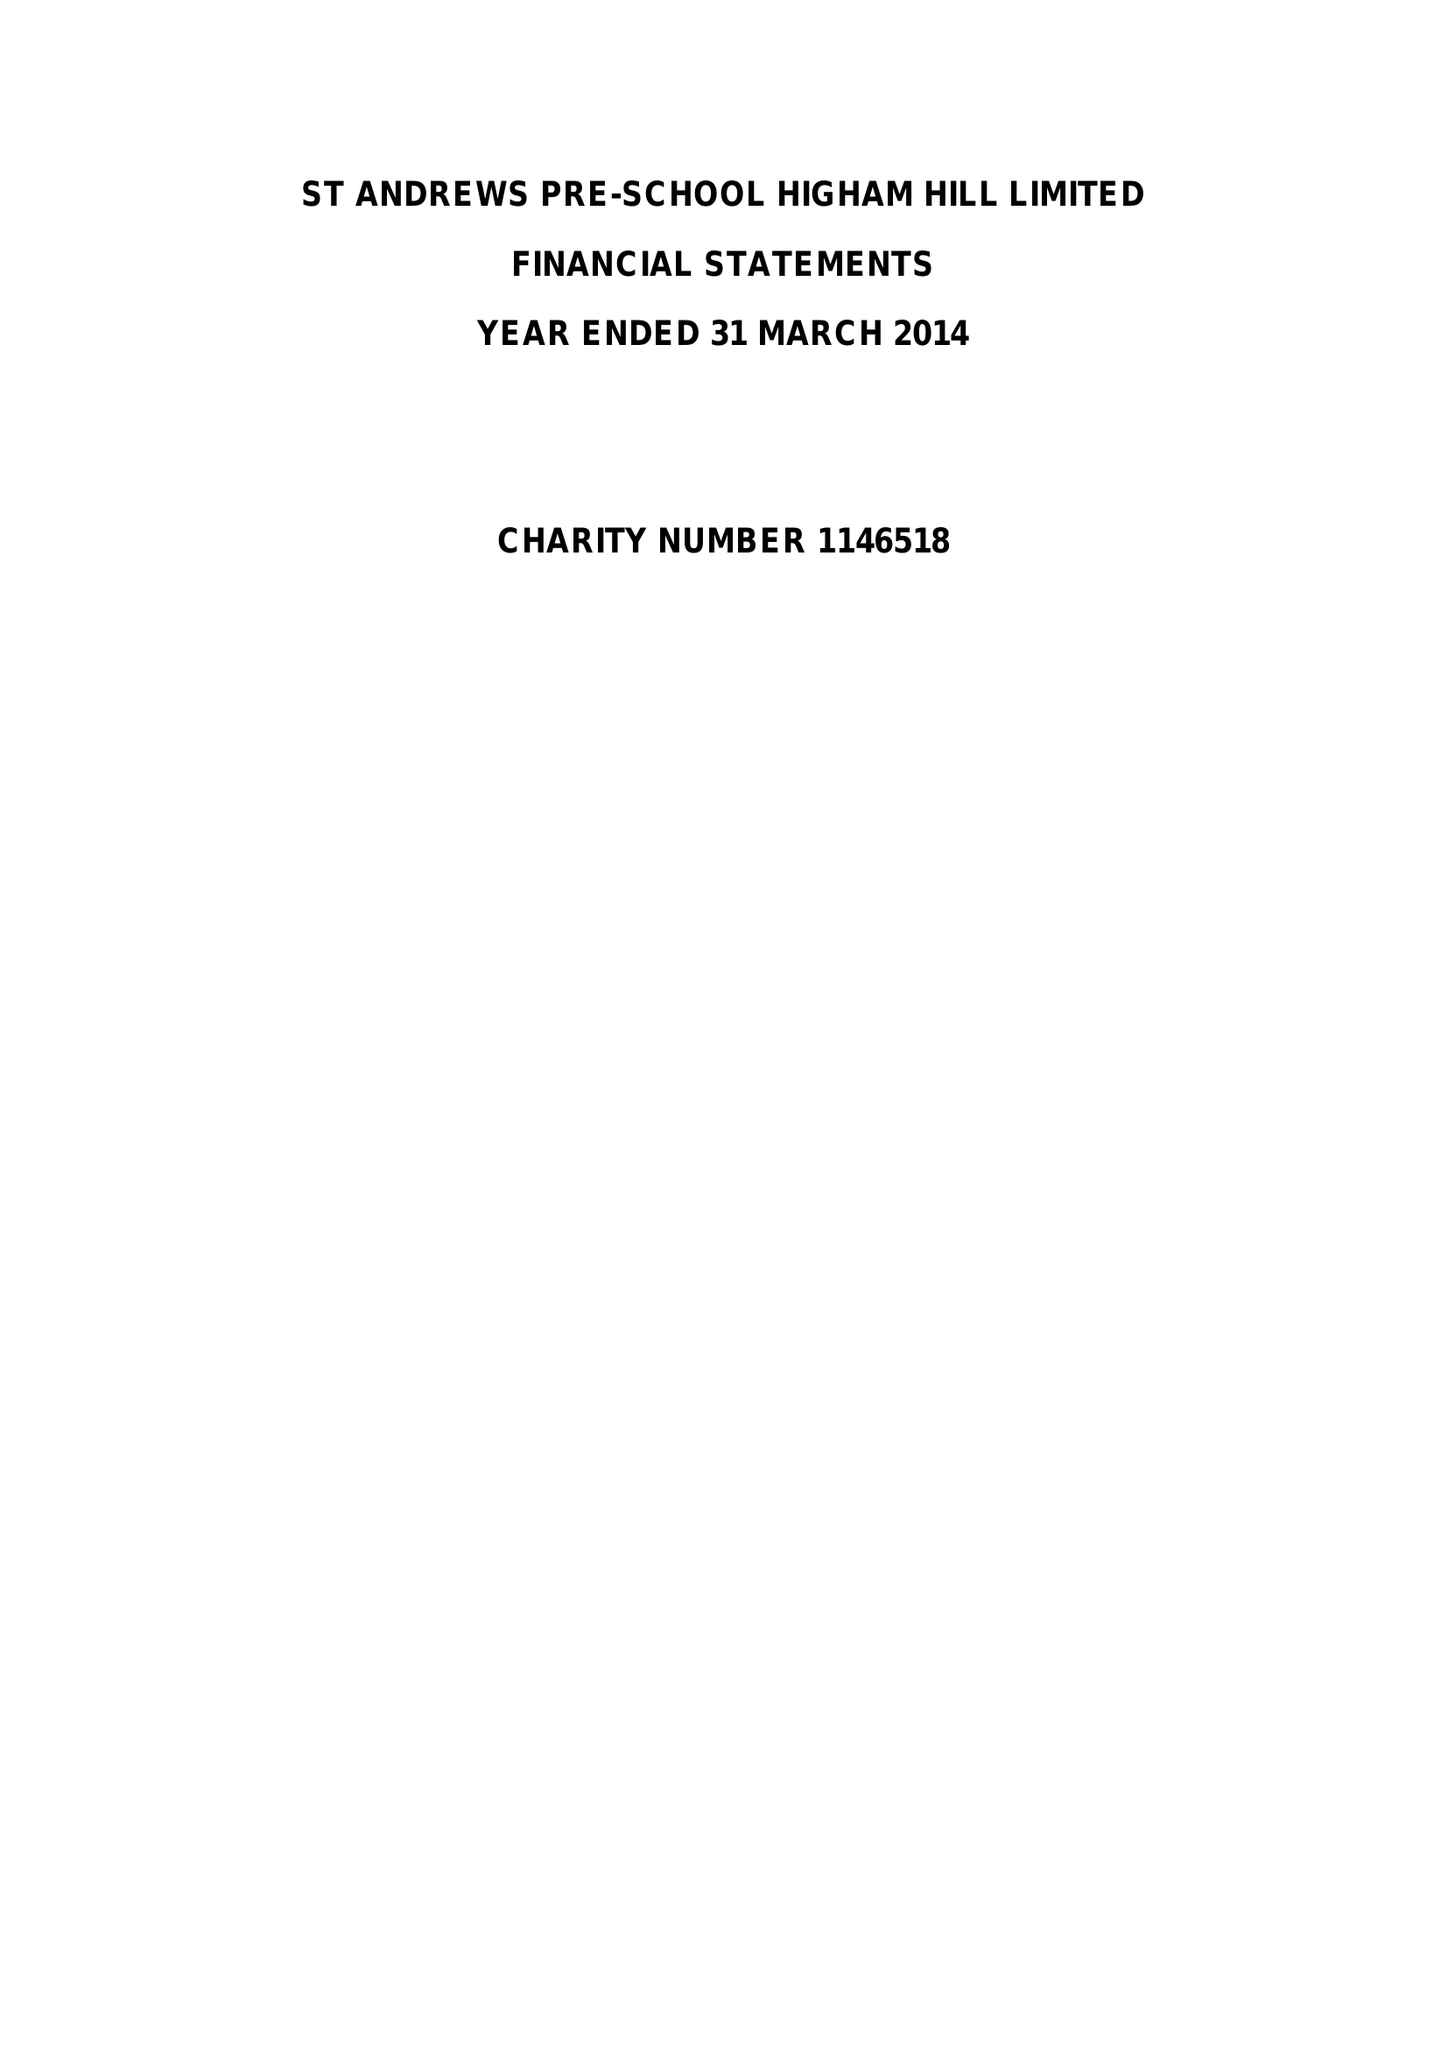What is the value for the report_date?
Answer the question using a single word or phrase. 2014-03-31 